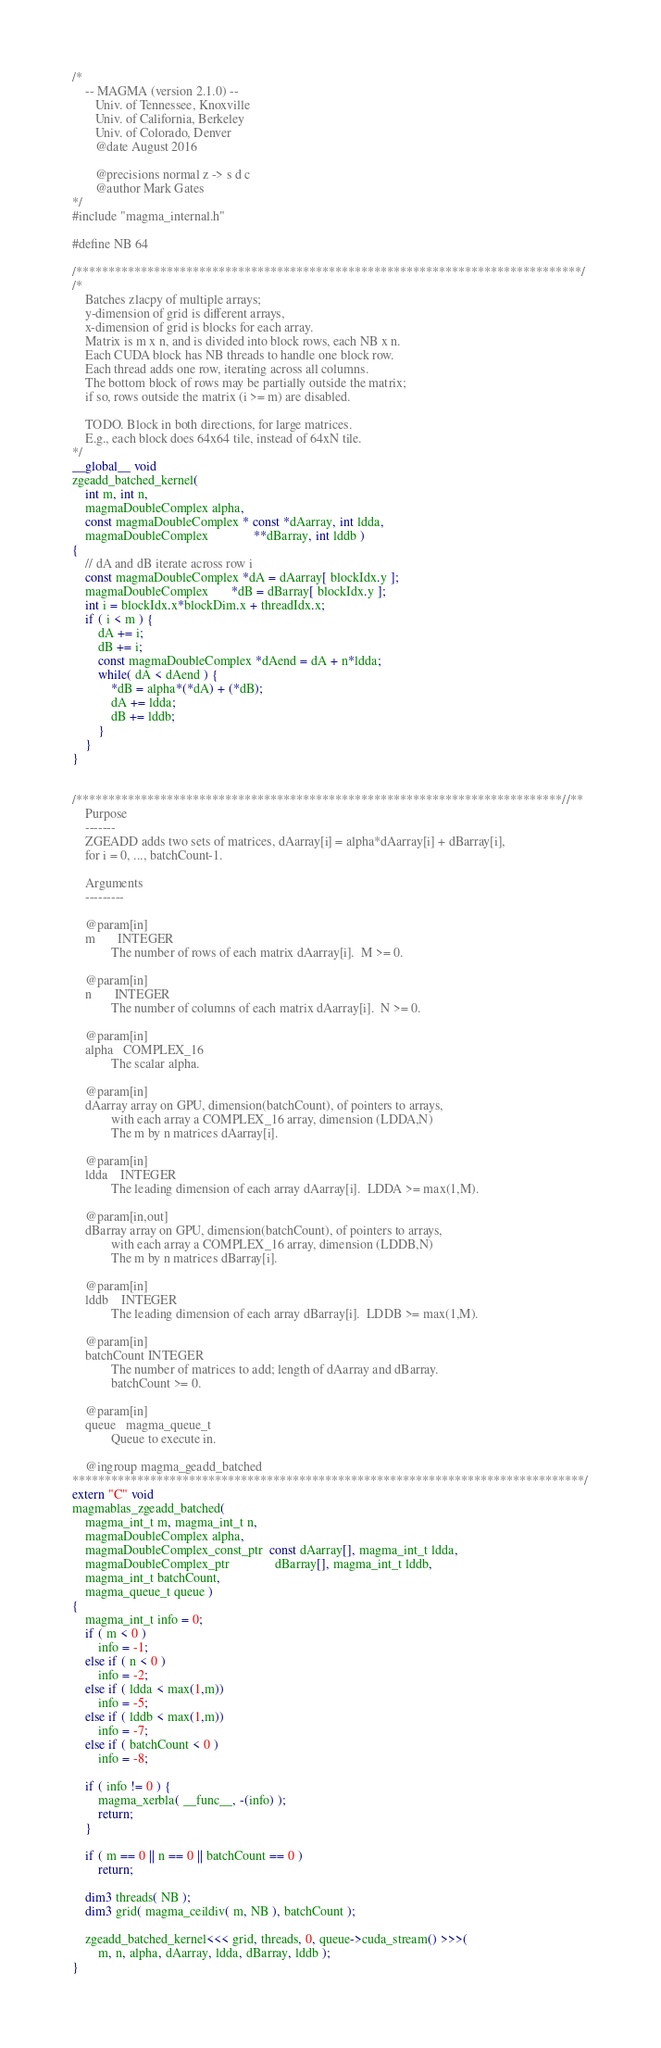<code> <loc_0><loc_0><loc_500><loc_500><_Cuda_>/*
    -- MAGMA (version 2.1.0) --
       Univ. of Tennessee, Knoxville
       Univ. of California, Berkeley
       Univ. of Colorado, Denver
       @date August 2016

       @precisions normal z -> s d c
       @author Mark Gates
*/
#include "magma_internal.h"

#define NB 64

/******************************************************************************/
/*
    Batches zlacpy of multiple arrays;
    y-dimension of grid is different arrays,
    x-dimension of grid is blocks for each array.
    Matrix is m x n, and is divided into block rows, each NB x n.
    Each CUDA block has NB threads to handle one block row.
    Each thread adds one row, iterating across all columns.
    The bottom block of rows may be partially outside the matrix;
    if so, rows outside the matrix (i >= m) are disabled.
    
    TODO. Block in both directions, for large matrices.
    E.g., each block does 64x64 tile, instead of 64xN tile.
*/
__global__ void
zgeadd_batched_kernel(
    int m, int n,
    magmaDoubleComplex alpha,
    const magmaDoubleComplex * const *dAarray, int ldda,
    magmaDoubleComplex              **dBarray, int lddb )
{
    // dA and dB iterate across row i
    const magmaDoubleComplex *dA = dAarray[ blockIdx.y ];
    magmaDoubleComplex       *dB = dBarray[ blockIdx.y ];
    int i = blockIdx.x*blockDim.x + threadIdx.x;
    if ( i < m ) {
        dA += i;
        dB += i;
        const magmaDoubleComplex *dAend = dA + n*ldda;
        while( dA < dAend ) {
            *dB = alpha*(*dA) + (*dB);
            dA += ldda;
            dB += lddb;
        }
    }
}


/***************************************************************************//**
    Purpose
    -------
    ZGEADD adds two sets of matrices, dAarray[i] = alpha*dAarray[i] + dBarray[i],
    for i = 0, ..., batchCount-1.
    
    Arguments
    ---------
    
    @param[in]
    m       INTEGER
            The number of rows of each matrix dAarray[i].  M >= 0.
    
    @param[in]
    n       INTEGER
            The number of columns of each matrix dAarray[i].  N >= 0.
    
    @param[in]
    alpha   COMPLEX_16
            The scalar alpha.
            
    @param[in]
    dAarray array on GPU, dimension(batchCount), of pointers to arrays,
            with each array a COMPLEX_16 array, dimension (LDDA,N)
            The m by n matrices dAarray[i].
    
    @param[in]
    ldda    INTEGER
            The leading dimension of each array dAarray[i].  LDDA >= max(1,M).
            
    @param[in,out]
    dBarray array on GPU, dimension(batchCount), of pointers to arrays,
            with each array a COMPLEX_16 array, dimension (LDDB,N)
            The m by n matrices dBarray[i].
    
    @param[in]
    lddb    INTEGER
            The leading dimension of each array dBarray[i].  LDDB >= max(1,M).
    
    @param[in]
    batchCount INTEGER
            The number of matrices to add; length of dAarray and dBarray.
            batchCount >= 0.
    
    @param[in]
    queue   magma_queue_t
            Queue to execute in.

    @ingroup magma_geadd_batched
*******************************************************************************/
extern "C" void
magmablas_zgeadd_batched(
    magma_int_t m, magma_int_t n,
    magmaDoubleComplex alpha,
    magmaDoubleComplex_const_ptr  const dAarray[], magma_int_t ldda,
    magmaDoubleComplex_ptr              dBarray[], magma_int_t lddb,
    magma_int_t batchCount,
    magma_queue_t queue )
{
    magma_int_t info = 0;
    if ( m < 0 )
        info = -1;
    else if ( n < 0 )
        info = -2;
    else if ( ldda < max(1,m))
        info = -5;
    else if ( lddb < max(1,m))
        info = -7;
    else if ( batchCount < 0 )
        info = -8;
    
    if ( info != 0 ) {
        magma_xerbla( __func__, -(info) );
        return;
    }
    
    if ( m == 0 || n == 0 || batchCount == 0 )
        return;
    
    dim3 threads( NB );
    dim3 grid( magma_ceildiv( m, NB ), batchCount );
    
    zgeadd_batched_kernel<<< grid, threads, 0, queue->cuda_stream() >>>(
        m, n, alpha, dAarray, ldda, dBarray, lddb );
}
</code> 